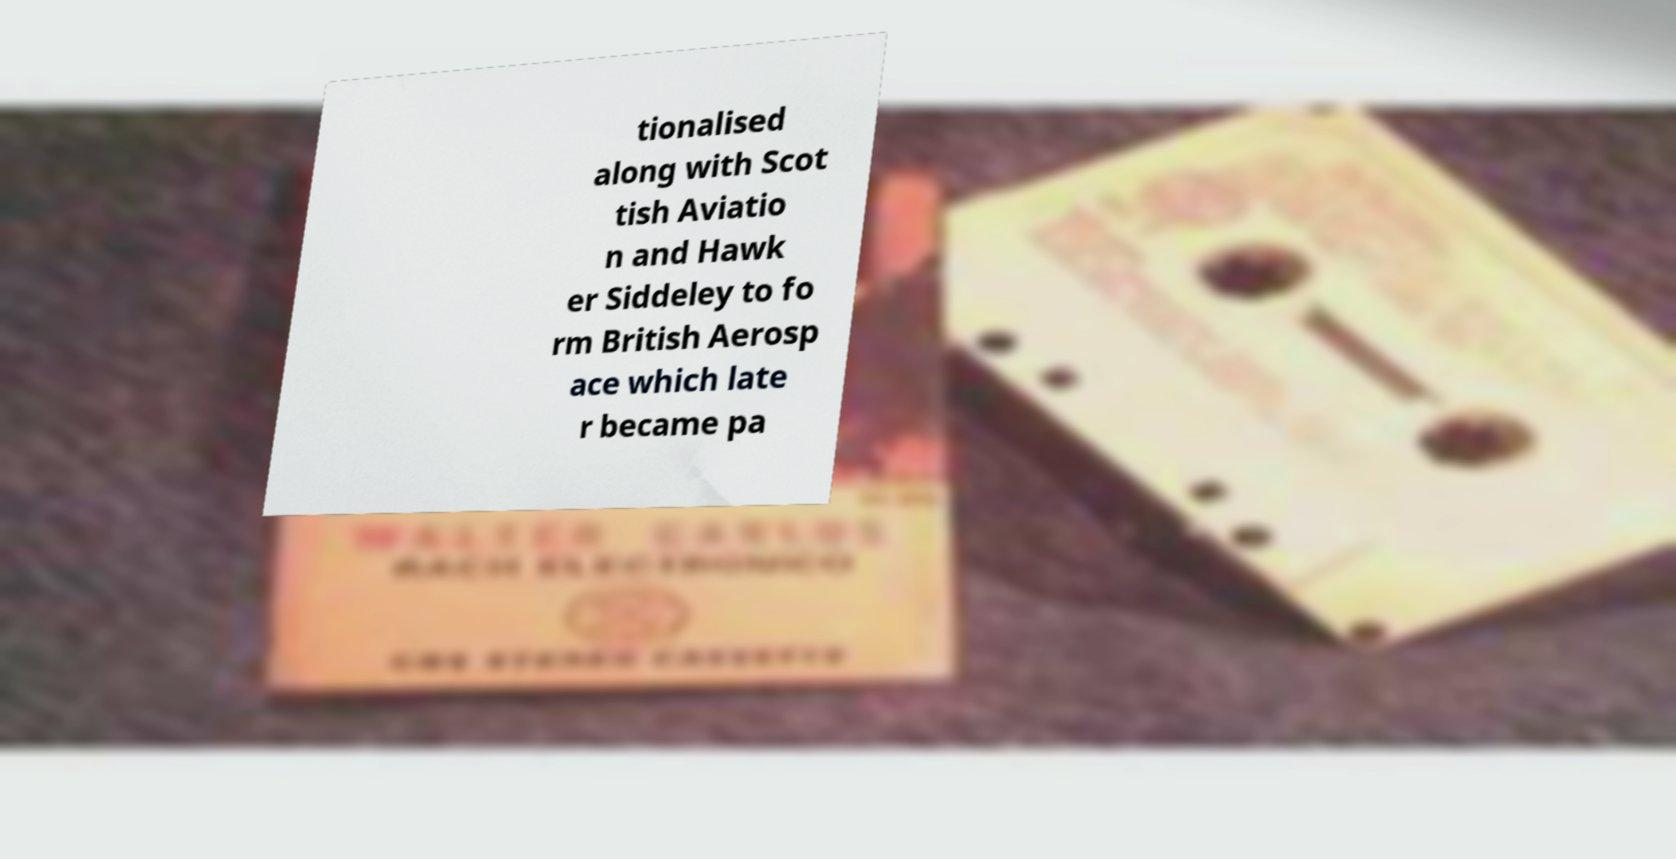Could you extract and type out the text from this image? tionalised along with Scot tish Aviatio n and Hawk er Siddeley to fo rm British Aerosp ace which late r became pa 